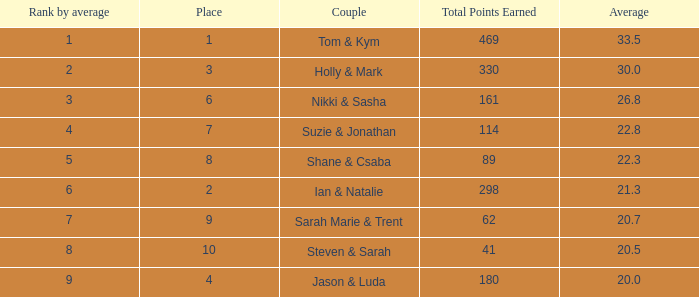What was the name of the couple if the number of dances is 6? Nikki & Sasha. Would you mind parsing the complete table? {'header': ['Rank by average', 'Place', 'Couple', 'Total Points Earned', 'Average'], 'rows': [['1', '1', 'Tom & Kym', '469', '33.5'], ['2', '3', 'Holly & Mark', '330', '30.0'], ['3', '6', 'Nikki & Sasha', '161', '26.8'], ['4', '7', 'Suzie & Jonathan', '114', '22.8'], ['5', '8', 'Shane & Csaba', '89', '22.3'], ['6', '2', 'Ian & Natalie', '298', '21.3'], ['7', '9', 'Sarah Marie & Trent', '62', '20.7'], ['8', '10', 'Steven & Sarah', '41', '20.5'], ['9', '4', 'Jason & Luda', '180', '20.0']]} 